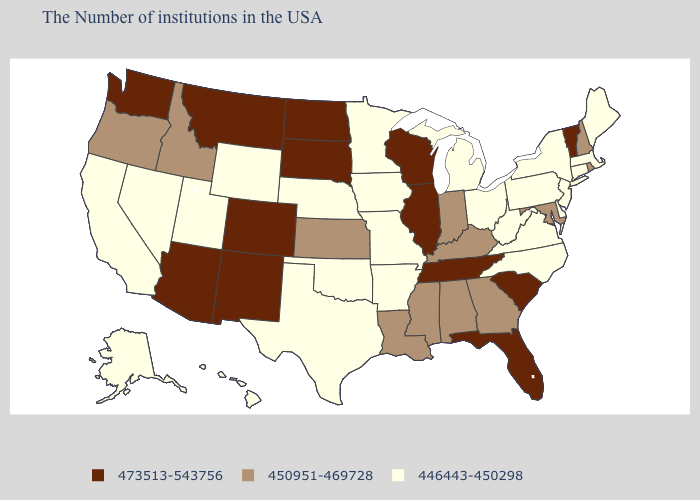Name the states that have a value in the range 446443-450298?
Answer briefly. Maine, Massachusetts, Connecticut, New York, New Jersey, Delaware, Pennsylvania, Virginia, North Carolina, West Virginia, Ohio, Michigan, Missouri, Arkansas, Minnesota, Iowa, Nebraska, Oklahoma, Texas, Wyoming, Utah, Nevada, California, Alaska, Hawaii. What is the highest value in the MidWest ?
Be succinct. 473513-543756. Name the states that have a value in the range 473513-543756?
Answer briefly. Vermont, South Carolina, Florida, Tennessee, Wisconsin, Illinois, South Dakota, North Dakota, Colorado, New Mexico, Montana, Arizona, Washington. What is the value of Nebraska?
Quick response, please. 446443-450298. Does Arkansas have the lowest value in the USA?
Quick response, please. Yes. What is the lowest value in the USA?
Be succinct. 446443-450298. Name the states that have a value in the range 446443-450298?
Give a very brief answer. Maine, Massachusetts, Connecticut, New York, New Jersey, Delaware, Pennsylvania, Virginia, North Carolina, West Virginia, Ohio, Michigan, Missouri, Arkansas, Minnesota, Iowa, Nebraska, Oklahoma, Texas, Wyoming, Utah, Nevada, California, Alaska, Hawaii. Among the states that border Vermont , does New Hampshire have the lowest value?
Concise answer only. No. Name the states that have a value in the range 450951-469728?
Quick response, please. Rhode Island, New Hampshire, Maryland, Georgia, Kentucky, Indiana, Alabama, Mississippi, Louisiana, Kansas, Idaho, Oregon. What is the lowest value in the South?
Give a very brief answer. 446443-450298. What is the highest value in the South ?
Quick response, please. 473513-543756. Does Maine have the same value as Oklahoma?
Be succinct. Yes. Does Washington have the lowest value in the USA?
Concise answer only. No. How many symbols are there in the legend?
Write a very short answer. 3. Does Utah have the lowest value in the USA?
Write a very short answer. Yes. 